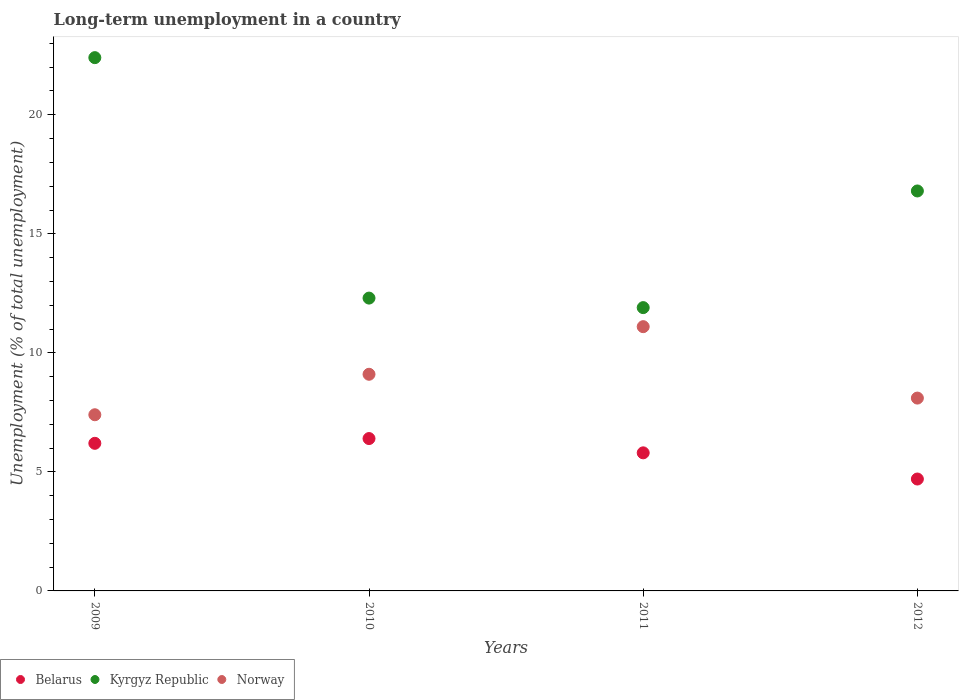How many different coloured dotlines are there?
Ensure brevity in your answer.  3. Is the number of dotlines equal to the number of legend labels?
Ensure brevity in your answer.  Yes. What is the percentage of long-term unemployed population in Kyrgyz Republic in 2012?
Offer a terse response. 16.8. Across all years, what is the maximum percentage of long-term unemployed population in Kyrgyz Republic?
Give a very brief answer. 22.4. Across all years, what is the minimum percentage of long-term unemployed population in Kyrgyz Republic?
Provide a succinct answer. 11.9. What is the total percentage of long-term unemployed population in Norway in the graph?
Offer a terse response. 35.7. What is the difference between the percentage of long-term unemployed population in Kyrgyz Republic in 2009 and that in 2011?
Give a very brief answer. 10.5. What is the difference between the percentage of long-term unemployed population in Kyrgyz Republic in 2011 and the percentage of long-term unemployed population in Norway in 2012?
Give a very brief answer. 3.8. What is the average percentage of long-term unemployed population in Kyrgyz Republic per year?
Give a very brief answer. 15.85. In the year 2010, what is the difference between the percentage of long-term unemployed population in Kyrgyz Republic and percentage of long-term unemployed population in Norway?
Your answer should be very brief. 3.2. What is the ratio of the percentage of long-term unemployed population in Kyrgyz Republic in 2009 to that in 2010?
Provide a short and direct response. 1.82. What is the difference between the highest and the second highest percentage of long-term unemployed population in Norway?
Make the answer very short. 2. What is the difference between the highest and the lowest percentage of long-term unemployed population in Kyrgyz Republic?
Give a very brief answer. 10.5. In how many years, is the percentage of long-term unemployed population in Kyrgyz Republic greater than the average percentage of long-term unemployed population in Kyrgyz Republic taken over all years?
Make the answer very short. 2. Is the sum of the percentage of long-term unemployed population in Norway in 2009 and 2011 greater than the maximum percentage of long-term unemployed population in Belarus across all years?
Your answer should be very brief. Yes. Is it the case that in every year, the sum of the percentage of long-term unemployed population in Kyrgyz Republic and percentage of long-term unemployed population in Belarus  is greater than the percentage of long-term unemployed population in Norway?
Make the answer very short. Yes. How many dotlines are there?
Ensure brevity in your answer.  3. How many years are there in the graph?
Provide a succinct answer. 4. What is the difference between two consecutive major ticks on the Y-axis?
Give a very brief answer. 5. Does the graph contain any zero values?
Your answer should be compact. No. Where does the legend appear in the graph?
Provide a succinct answer. Bottom left. How are the legend labels stacked?
Make the answer very short. Horizontal. What is the title of the graph?
Your answer should be compact. Long-term unemployment in a country. Does "Sri Lanka" appear as one of the legend labels in the graph?
Your answer should be compact. No. What is the label or title of the Y-axis?
Ensure brevity in your answer.  Unemployment (% of total unemployment). What is the Unemployment (% of total unemployment) in Belarus in 2009?
Your answer should be very brief. 6.2. What is the Unemployment (% of total unemployment) of Kyrgyz Republic in 2009?
Provide a succinct answer. 22.4. What is the Unemployment (% of total unemployment) in Norway in 2009?
Your answer should be compact. 7.4. What is the Unemployment (% of total unemployment) in Belarus in 2010?
Ensure brevity in your answer.  6.4. What is the Unemployment (% of total unemployment) of Kyrgyz Republic in 2010?
Offer a very short reply. 12.3. What is the Unemployment (% of total unemployment) in Norway in 2010?
Provide a succinct answer. 9.1. What is the Unemployment (% of total unemployment) of Belarus in 2011?
Give a very brief answer. 5.8. What is the Unemployment (% of total unemployment) in Kyrgyz Republic in 2011?
Make the answer very short. 11.9. What is the Unemployment (% of total unemployment) in Norway in 2011?
Keep it short and to the point. 11.1. What is the Unemployment (% of total unemployment) of Belarus in 2012?
Offer a very short reply. 4.7. What is the Unemployment (% of total unemployment) of Kyrgyz Republic in 2012?
Keep it short and to the point. 16.8. What is the Unemployment (% of total unemployment) of Norway in 2012?
Offer a terse response. 8.1. Across all years, what is the maximum Unemployment (% of total unemployment) of Belarus?
Offer a terse response. 6.4. Across all years, what is the maximum Unemployment (% of total unemployment) in Kyrgyz Republic?
Keep it short and to the point. 22.4. Across all years, what is the maximum Unemployment (% of total unemployment) in Norway?
Your answer should be compact. 11.1. Across all years, what is the minimum Unemployment (% of total unemployment) in Belarus?
Your response must be concise. 4.7. Across all years, what is the minimum Unemployment (% of total unemployment) in Kyrgyz Republic?
Ensure brevity in your answer.  11.9. Across all years, what is the minimum Unemployment (% of total unemployment) of Norway?
Provide a short and direct response. 7.4. What is the total Unemployment (% of total unemployment) in Belarus in the graph?
Keep it short and to the point. 23.1. What is the total Unemployment (% of total unemployment) in Kyrgyz Republic in the graph?
Your response must be concise. 63.4. What is the total Unemployment (% of total unemployment) in Norway in the graph?
Provide a succinct answer. 35.7. What is the difference between the Unemployment (% of total unemployment) of Belarus in 2009 and that in 2010?
Ensure brevity in your answer.  -0.2. What is the difference between the Unemployment (% of total unemployment) of Belarus in 2009 and that in 2011?
Your answer should be very brief. 0.4. What is the difference between the Unemployment (% of total unemployment) of Norway in 2009 and that in 2011?
Provide a short and direct response. -3.7. What is the difference between the Unemployment (% of total unemployment) in Belarus in 2009 and that in 2012?
Your answer should be very brief. 1.5. What is the difference between the Unemployment (% of total unemployment) in Kyrgyz Republic in 2009 and that in 2012?
Your answer should be very brief. 5.6. What is the difference between the Unemployment (% of total unemployment) in Norway in 2010 and that in 2011?
Your response must be concise. -2. What is the difference between the Unemployment (% of total unemployment) of Belarus in 2010 and that in 2012?
Keep it short and to the point. 1.7. What is the difference between the Unemployment (% of total unemployment) of Kyrgyz Republic in 2010 and that in 2012?
Your response must be concise. -4.5. What is the difference between the Unemployment (% of total unemployment) of Belarus in 2011 and that in 2012?
Make the answer very short. 1.1. What is the difference between the Unemployment (% of total unemployment) of Norway in 2011 and that in 2012?
Ensure brevity in your answer.  3. What is the difference between the Unemployment (% of total unemployment) in Belarus in 2009 and the Unemployment (% of total unemployment) in Kyrgyz Republic in 2010?
Your response must be concise. -6.1. What is the difference between the Unemployment (% of total unemployment) of Belarus in 2009 and the Unemployment (% of total unemployment) of Norway in 2011?
Give a very brief answer. -4.9. What is the difference between the Unemployment (% of total unemployment) in Belarus in 2009 and the Unemployment (% of total unemployment) in Norway in 2012?
Your response must be concise. -1.9. What is the difference between the Unemployment (% of total unemployment) in Belarus in 2010 and the Unemployment (% of total unemployment) in Norway in 2011?
Ensure brevity in your answer.  -4.7. What is the difference between the Unemployment (% of total unemployment) in Kyrgyz Republic in 2010 and the Unemployment (% of total unemployment) in Norway in 2011?
Make the answer very short. 1.2. What is the difference between the Unemployment (% of total unemployment) of Belarus in 2010 and the Unemployment (% of total unemployment) of Kyrgyz Republic in 2012?
Your answer should be compact. -10.4. What is the difference between the Unemployment (% of total unemployment) in Kyrgyz Republic in 2010 and the Unemployment (% of total unemployment) in Norway in 2012?
Provide a succinct answer. 4.2. What is the difference between the Unemployment (% of total unemployment) in Belarus in 2011 and the Unemployment (% of total unemployment) in Kyrgyz Republic in 2012?
Offer a terse response. -11. What is the difference between the Unemployment (% of total unemployment) of Belarus in 2011 and the Unemployment (% of total unemployment) of Norway in 2012?
Offer a very short reply. -2.3. What is the average Unemployment (% of total unemployment) of Belarus per year?
Your response must be concise. 5.78. What is the average Unemployment (% of total unemployment) in Kyrgyz Republic per year?
Offer a very short reply. 15.85. What is the average Unemployment (% of total unemployment) of Norway per year?
Offer a terse response. 8.93. In the year 2009, what is the difference between the Unemployment (% of total unemployment) of Belarus and Unemployment (% of total unemployment) of Kyrgyz Republic?
Offer a terse response. -16.2. In the year 2009, what is the difference between the Unemployment (% of total unemployment) of Kyrgyz Republic and Unemployment (% of total unemployment) of Norway?
Your answer should be very brief. 15. In the year 2010, what is the difference between the Unemployment (% of total unemployment) in Belarus and Unemployment (% of total unemployment) in Norway?
Give a very brief answer. -2.7. In the year 2010, what is the difference between the Unemployment (% of total unemployment) in Kyrgyz Republic and Unemployment (% of total unemployment) in Norway?
Offer a very short reply. 3.2. In the year 2011, what is the difference between the Unemployment (% of total unemployment) in Belarus and Unemployment (% of total unemployment) in Norway?
Keep it short and to the point. -5.3. In the year 2011, what is the difference between the Unemployment (% of total unemployment) in Kyrgyz Republic and Unemployment (% of total unemployment) in Norway?
Provide a succinct answer. 0.8. In the year 2012, what is the difference between the Unemployment (% of total unemployment) of Belarus and Unemployment (% of total unemployment) of Kyrgyz Republic?
Provide a short and direct response. -12.1. In the year 2012, what is the difference between the Unemployment (% of total unemployment) of Belarus and Unemployment (% of total unemployment) of Norway?
Make the answer very short. -3.4. What is the ratio of the Unemployment (% of total unemployment) of Belarus in 2009 to that in 2010?
Offer a terse response. 0.97. What is the ratio of the Unemployment (% of total unemployment) in Kyrgyz Republic in 2009 to that in 2010?
Offer a very short reply. 1.82. What is the ratio of the Unemployment (% of total unemployment) in Norway in 2009 to that in 2010?
Your answer should be compact. 0.81. What is the ratio of the Unemployment (% of total unemployment) of Belarus in 2009 to that in 2011?
Give a very brief answer. 1.07. What is the ratio of the Unemployment (% of total unemployment) in Kyrgyz Republic in 2009 to that in 2011?
Provide a short and direct response. 1.88. What is the ratio of the Unemployment (% of total unemployment) of Belarus in 2009 to that in 2012?
Offer a terse response. 1.32. What is the ratio of the Unemployment (% of total unemployment) in Kyrgyz Republic in 2009 to that in 2012?
Your answer should be compact. 1.33. What is the ratio of the Unemployment (% of total unemployment) in Norway in 2009 to that in 2012?
Keep it short and to the point. 0.91. What is the ratio of the Unemployment (% of total unemployment) of Belarus in 2010 to that in 2011?
Provide a short and direct response. 1.1. What is the ratio of the Unemployment (% of total unemployment) in Kyrgyz Republic in 2010 to that in 2011?
Your answer should be compact. 1.03. What is the ratio of the Unemployment (% of total unemployment) in Norway in 2010 to that in 2011?
Keep it short and to the point. 0.82. What is the ratio of the Unemployment (% of total unemployment) in Belarus in 2010 to that in 2012?
Your answer should be compact. 1.36. What is the ratio of the Unemployment (% of total unemployment) in Kyrgyz Republic in 2010 to that in 2012?
Keep it short and to the point. 0.73. What is the ratio of the Unemployment (% of total unemployment) of Norway in 2010 to that in 2012?
Make the answer very short. 1.12. What is the ratio of the Unemployment (% of total unemployment) in Belarus in 2011 to that in 2012?
Give a very brief answer. 1.23. What is the ratio of the Unemployment (% of total unemployment) in Kyrgyz Republic in 2011 to that in 2012?
Offer a terse response. 0.71. What is the ratio of the Unemployment (% of total unemployment) in Norway in 2011 to that in 2012?
Offer a very short reply. 1.37. What is the difference between the highest and the second highest Unemployment (% of total unemployment) of Norway?
Your answer should be compact. 2. What is the difference between the highest and the lowest Unemployment (% of total unemployment) of Belarus?
Offer a terse response. 1.7. What is the difference between the highest and the lowest Unemployment (% of total unemployment) in Kyrgyz Republic?
Keep it short and to the point. 10.5. What is the difference between the highest and the lowest Unemployment (% of total unemployment) in Norway?
Keep it short and to the point. 3.7. 